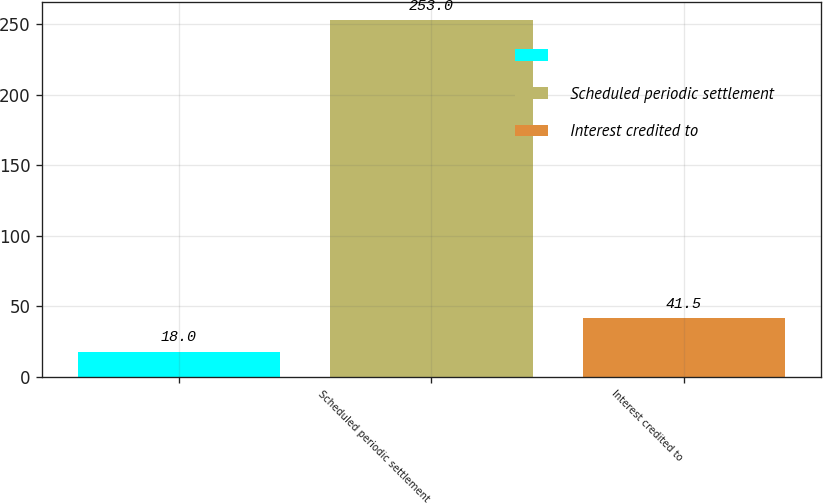Convert chart. <chart><loc_0><loc_0><loc_500><loc_500><bar_chart><ecel><fcel>Scheduled periodic settlement<fcel>Interest credited to<nl><fcel>18<fcel>253<fcel>41.5<nl></chart> 